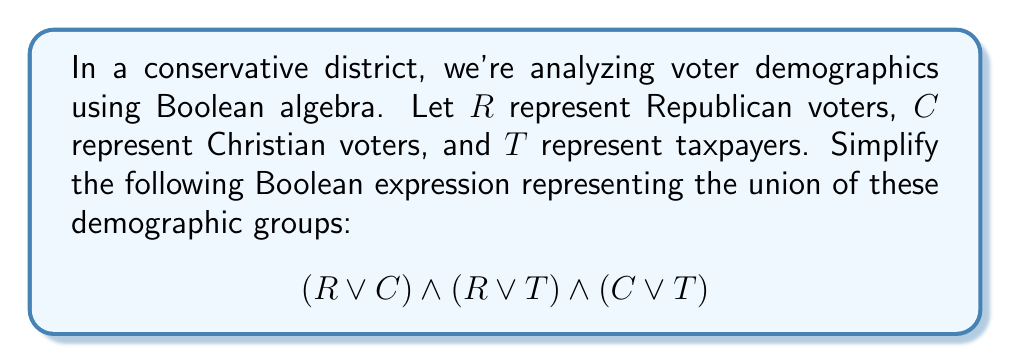Could you help me with this problem? Let's simplify this expression step-by-step using Boolean algebra laws:

1) First, we can apply the distributive law to expand the expression:
   $$(R \lor C) \land (R \lor T) \land (C \lor T)$$
   $= R \land (R \lor T) \land (C \lor T) \lor C \land (R \lor T) \land (C \lor T)$$

2) Simplify $R \land (R \lor T)$ to $R$ using absorption law:
   $= R \land (C \lor T) \lor C \land (R \lor T) \land (C \lor T)$$

3) Distribute $C$ over $(R \lor T)$ in the right term:
   $= R \land (C \lor T) \lor (C \land R \lor C \land T) \land (C \lor T)$$

4) Apply absorption law to $C \land (C \lor T)$, which simplifies to $C$:
   $= R \land (C \lor T) \lor (C \land R \lor C)$$

5) Simplify $(C \land R \lor C)$ to $C$ using absorption law:
   $= R \land (C \lor T) \lor C$$

6) Distribute $R$ over $(C \lor T)$:
   $= (R \land C \lor R \land T) \lor C$$

7) Use the commutative and associative laws to rearrange terms:
   $= R \land C \lor R \land T \lor C$$

8) Factor out $C$:
   $= C \lor (R \land T)$$

This final expression, $C \lor (R \land T)$, represents the simplified union of the demographic groups.
Answer: $C \lor (R \land T)$ 